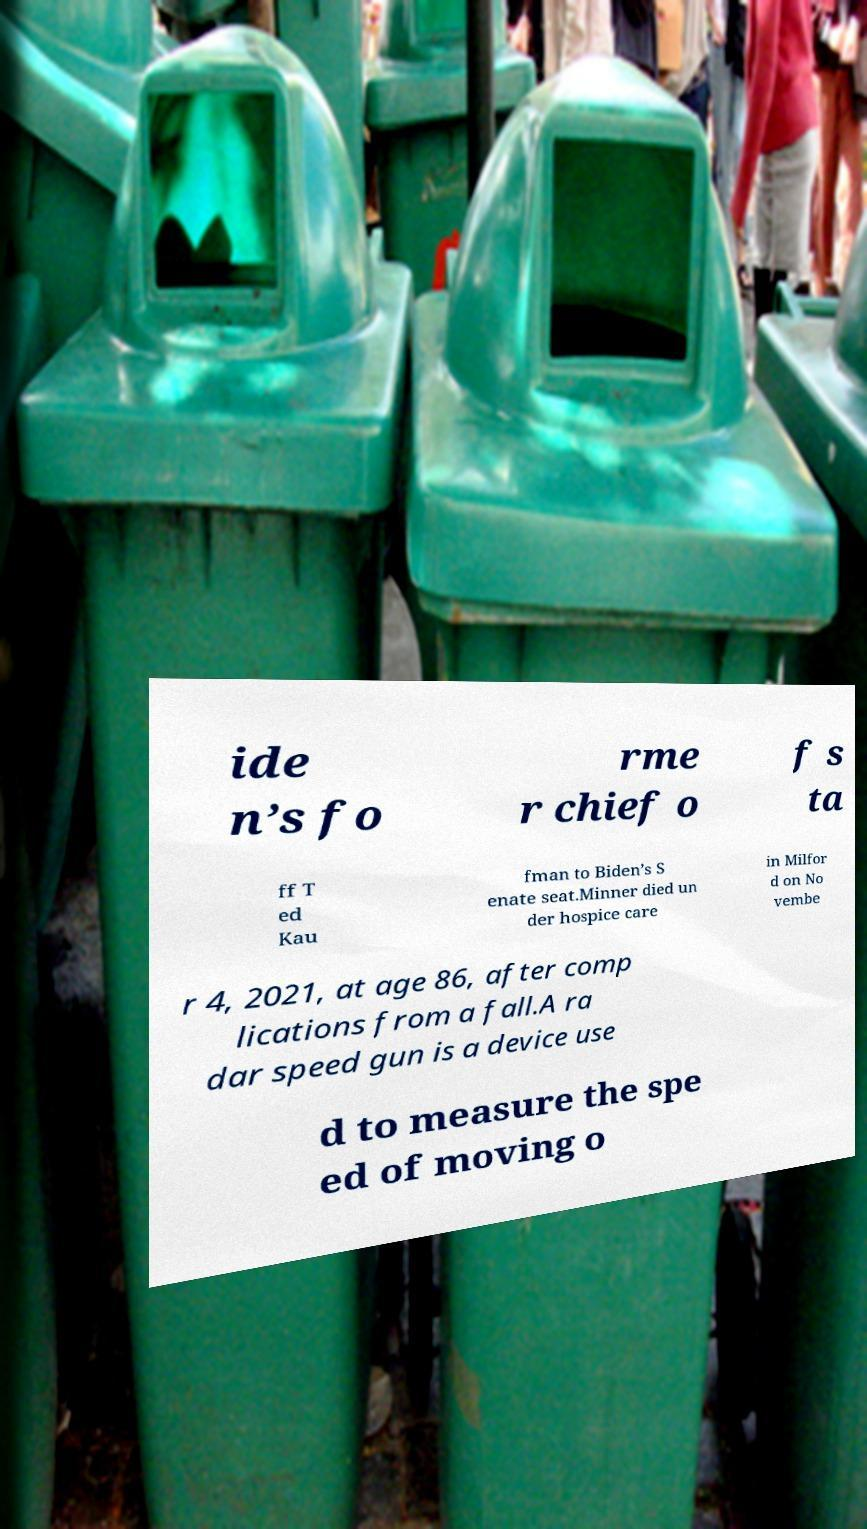Could you assist in decoding the text presented in this image and type it out clearly? ide n’s fo rme r chief o f s ta ff T ed Kau fman to Biden’s S enate seat.Minner died un der hospice care in Milfor d on No vembe r 4, 2021, at age 86, after comp lications from a fall.A ra dar speed gun is a device use d to measure the spe ed of moving o 